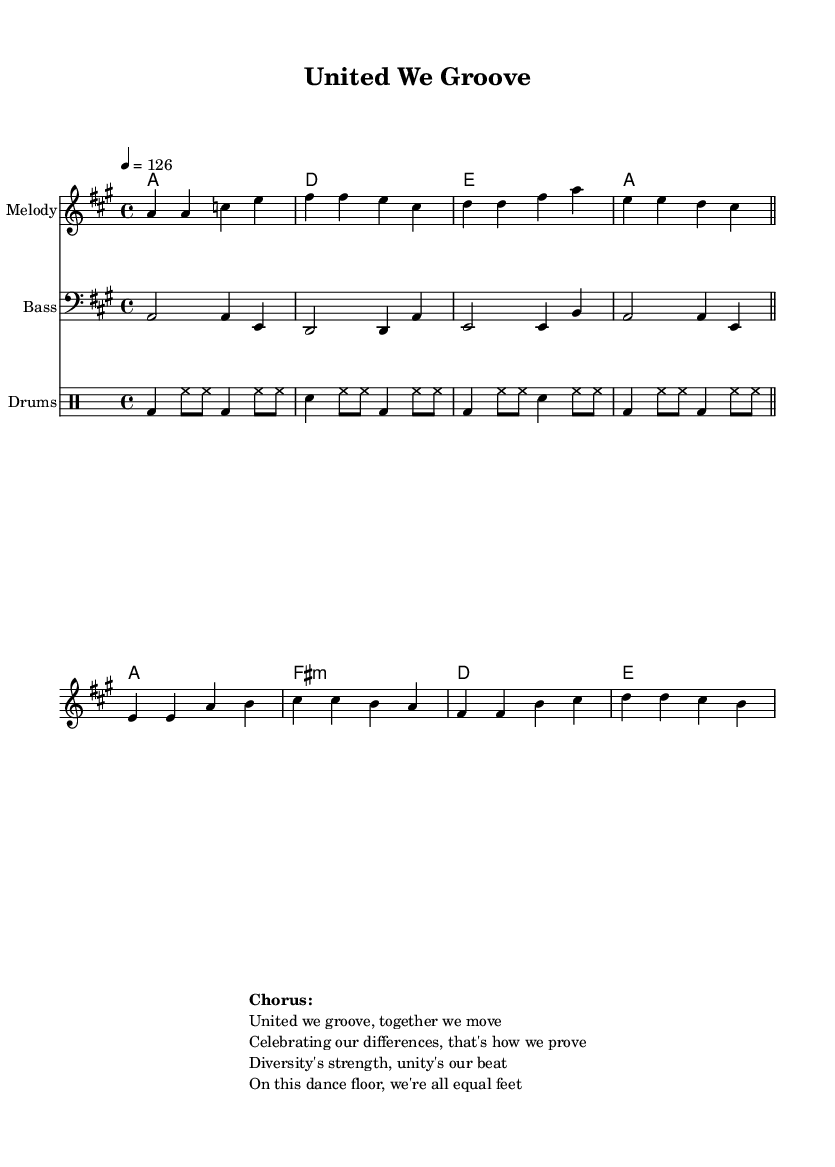What is the key signature of this music? The key signature is A major, which has three sharps: F#, C#, and G#. This is identified by observing the key signature at the beginning of the sheet music.
Answer: A major What is the time signature of this music? The time signature is 4/4, indicated by the '4' over '4' at the beginning of the score. This means there are four beats per measure, and the quarter note gets one beat.
Answer: 4/4 What is the tempo marking in this piece? The tempo marking is 4 beats per minute at 126, indicated by the 'tempo 4 = 126' marking in the global definition. This specifies the speed of the piece.
Answer: 126 How many measures are there in the chorus? The chorus consists of four measures. This can be determined by counting the sequences of notes separated by vertical lines in the melodyChorus section of the sheet music.
Answer: 4 What is the driving rhythmic pattern used in this drum part? The driving rhythmic pattern features a bass drum on the downbeats and hi-hats consistently played, creating a disco groove. This pattern can be identified by analyzing the drum part where the bass drum and hi-hat notes are prominently placed.
Answer: Bass and hi-hat What lyrical theme is represented in the chorus? The lyrical theme in the chorus focuses on diversity and unity, evident from phrases like "Celebrating our differences" and "Diversity's strength." This is analyzed by reading the text included in the markup section, which conveys the message of the song.
Answer: Diversity and unity Which instrument plays the bass line in this piece? The instrument playing the bass line is indicated as "Bass" in the score, which is explicitly labeled in the staff section of the sheet music.
Answer: Bass 